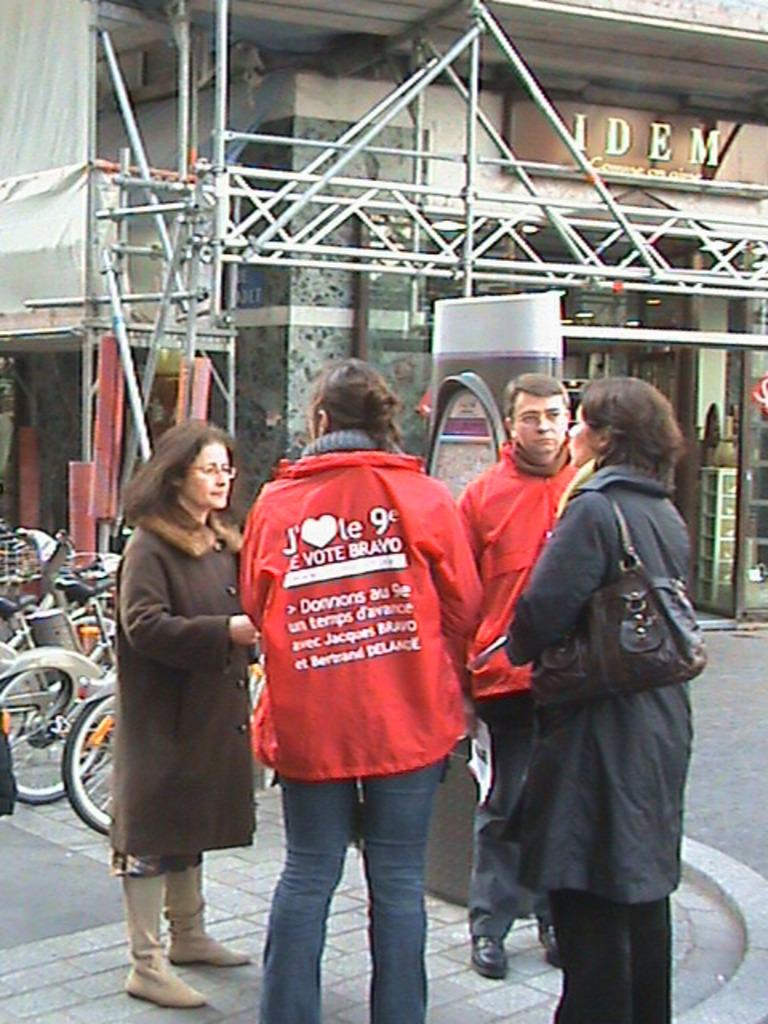What is located in the middle of the image? There are persons in the middle of the image. What can be seen on the left side of the image? There are bicycles on the left side of the image. What is visible in the background of the image? There is a store visible in the background of the image. What is on the wall on the right side of the image? There is a board on the wall on the right side of the image. Can you hear the sound of a leaf rustling in the image? There is no auditory information provided in the image, and leaves are not mentioned, so it is not possible to answer this question. 